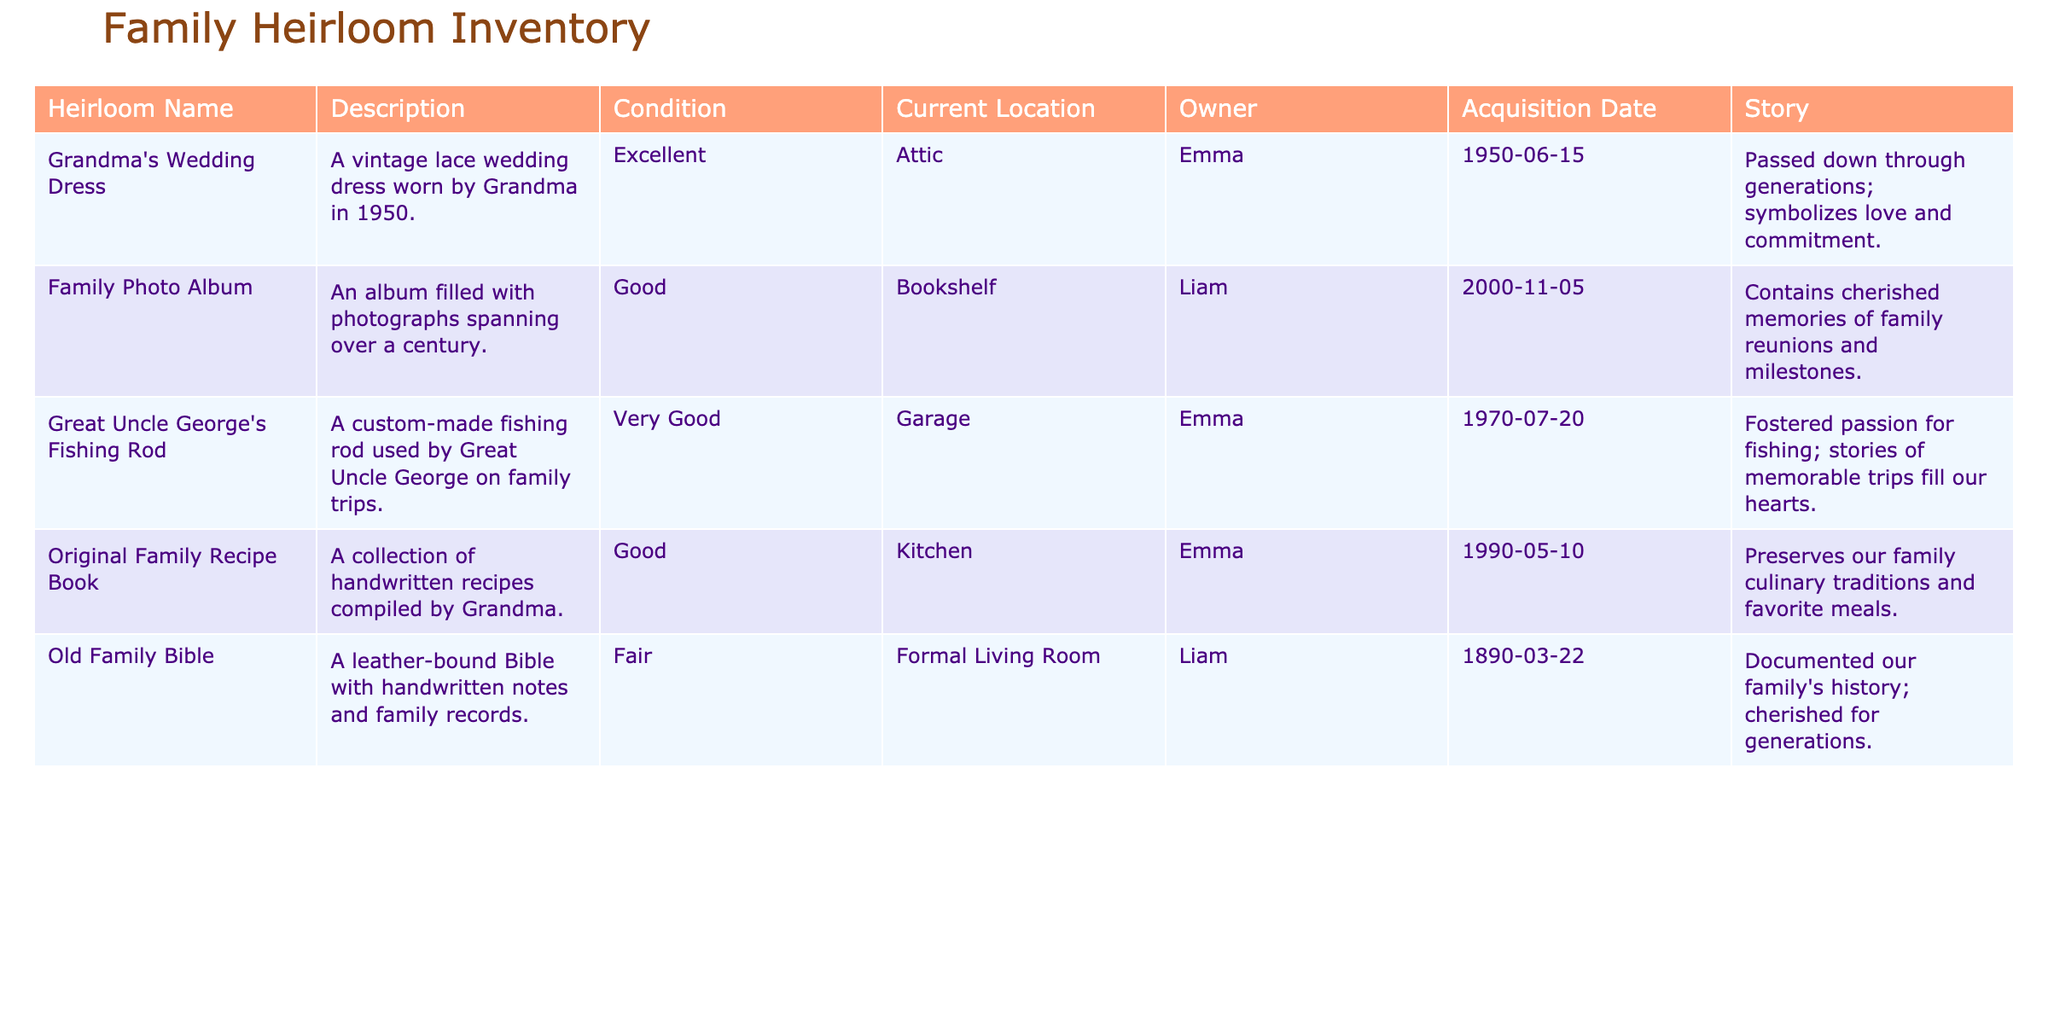What is the condition of Grandma's Wedding Dress? The condition of Grandma's Wedding Dress is listed in the table under the "Condition" column. It states "Excellent."
Answer: Excellent Where is the Old Family Bible currently located? The table shows the current location of the Old Family Bible under the "Current Location" column, which is "Formal Living Room."
Answer: Formal Living Room How many heirlooms are in 'Good' condition? To answer this, we look at the "Condition" column for "Good." The heirlooms in this condition are the Family Photo Album and the Original Family Recipe Book, amounting to 2 heirlooms.
Answer: 2 Is the Family Photo Album older than the Great Uncle George's Fishing Rod? We can determine this by checking the "Acquisition Date" for both items. The Family Photo Album has an acquisition date of 2000, while the Fishing Rod has a date of 1970. Since 2000 is later than 1970, the answer is no.
Answer: No Which owner has the most heirlooms listed? We examine the "Owner" column, counting the heirlooms associated with each owner. Emma has 3 heirlooms (Wedding Dress, Fishing Rod, and Recipe Book), while Liam has 2. Thus, Emma is the owner with the most heirlooms.
Answer: Emma What story is associated with the Original Family Recipe Book? By locating the Original Family Recipe Book in the "Story" column, we find that it states, "Preserves our family culinary traditions and favorite meals."
Answer: Preserves our family culinary traditions and favorite meals Which heirloom has the oldest acquisition date? The acquisition dates must be checked in the "Acquisition Date" column. The Old Family Bible, with an acquisition date of 1890, is the oldest among all listed heirlooms compared to the others.
Answer: Old Family Bible Are there any heirlooms currently located in the garage? We can find this information in the "Current Location" column. The Great Uncle George's Fishing Rod is specifically listed as being in the garage, which confirms that yes, there is an heirloom located there.
Answer: Yes What relationship did Great Uncle George's Fishing Rod foster within the family? The "Story" for Great Uncle George's Fishing Rod says it "Fostered passion for fishing; stories of memorable trips fill our hearts." This shows that it brought the family closer through shared experiences.
Answer: Fostered passion for fishing and shared stories 